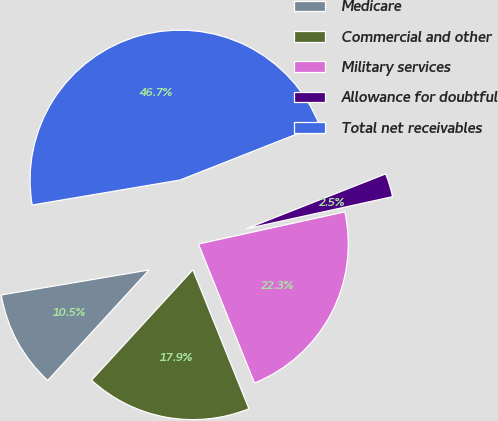Convert chart. <chart><loc_0><loc_0><loc_500><loc_500><pie_chart><fcel>Medicare<fcel>Commercial and other<fcel>Military services<fcel>Allowance for doubtful<fcel>Total net receivables<nl><fcel>10.52%<fcel>17.92%<fcel>22.34%<fcel>2.53%<fcel>46.7%<nl></chart> 